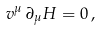Convert formula to latex. <formula><loc_0><loc_0><loc_500><loc_500>v ^ { \mu } \, \partial _ { \mu } H = 0 \, ,</formula> 